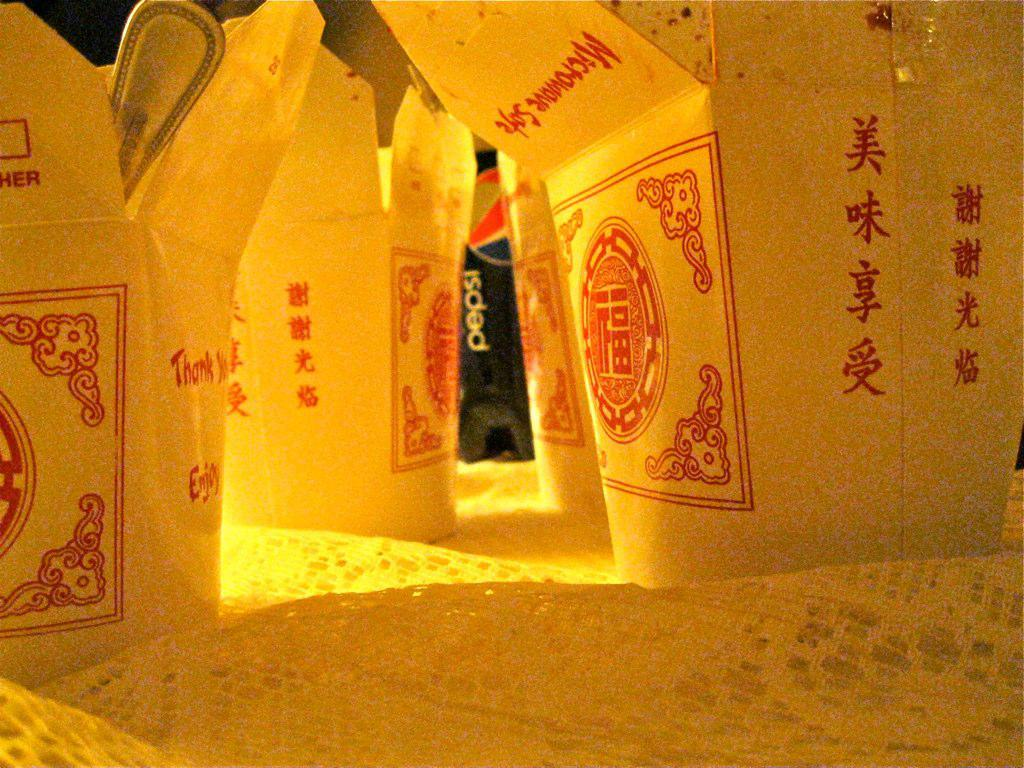<image>
Offer a succinct explanation of the picture presented. A bottle of Pepsi is visible behind a collection of take out containers. 